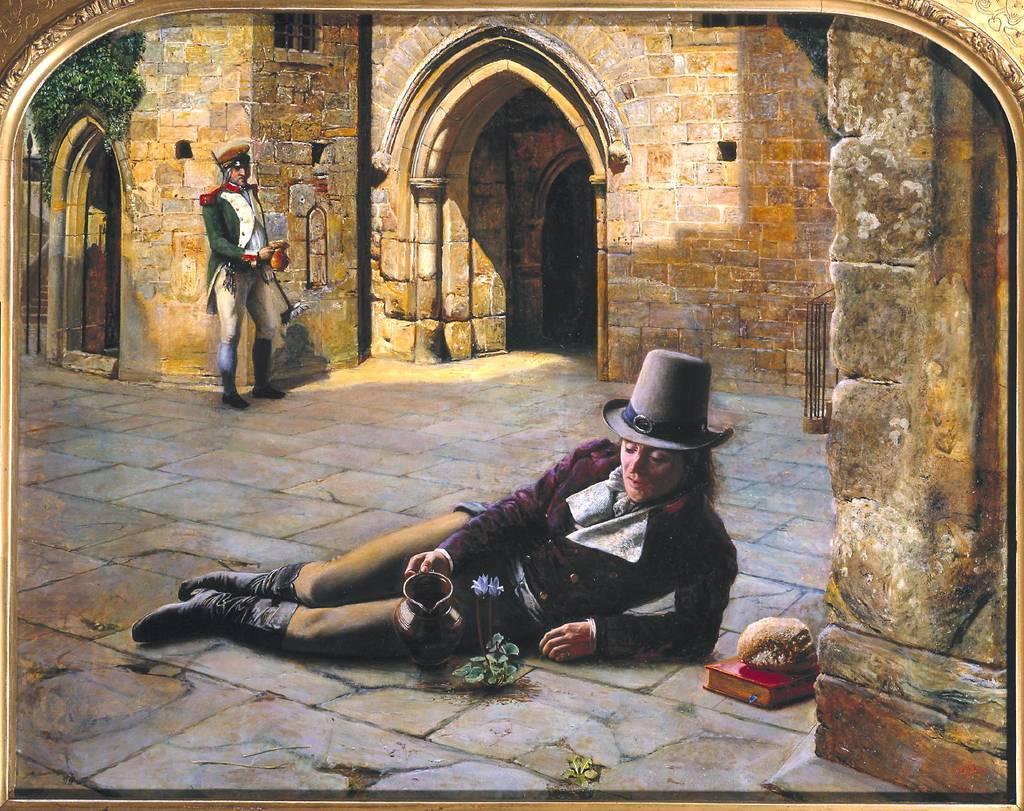What is the sleeping person doing in the image? The sleeping person is lying on the floor in the image. What is the sleeping person holding? The sleeping person is holding a mug. Can you describe the position of the standing person in relation to the sleeping person? The standing person is behind the sleeping person. What is the building in the image made of? The building in the image is made of stone. What type of print can be seen on the body of the sleeping person? There is no print visible on the body of the sleeping person in the image. 